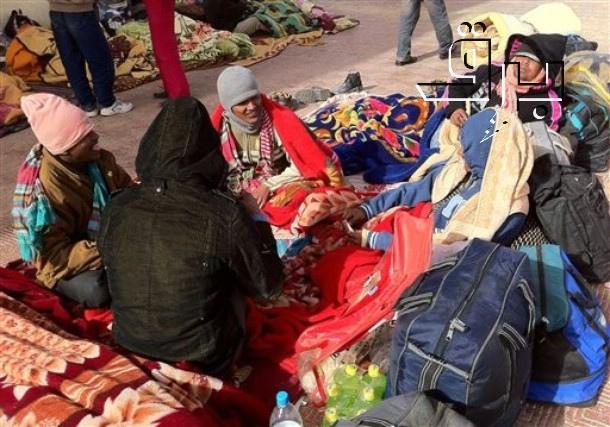What shows that these people are cold?
Answer briefly. Coats. How many people can we see standing?
Write a very short answer. 3. Are these people camping in the woods?
Short answer required. No. 